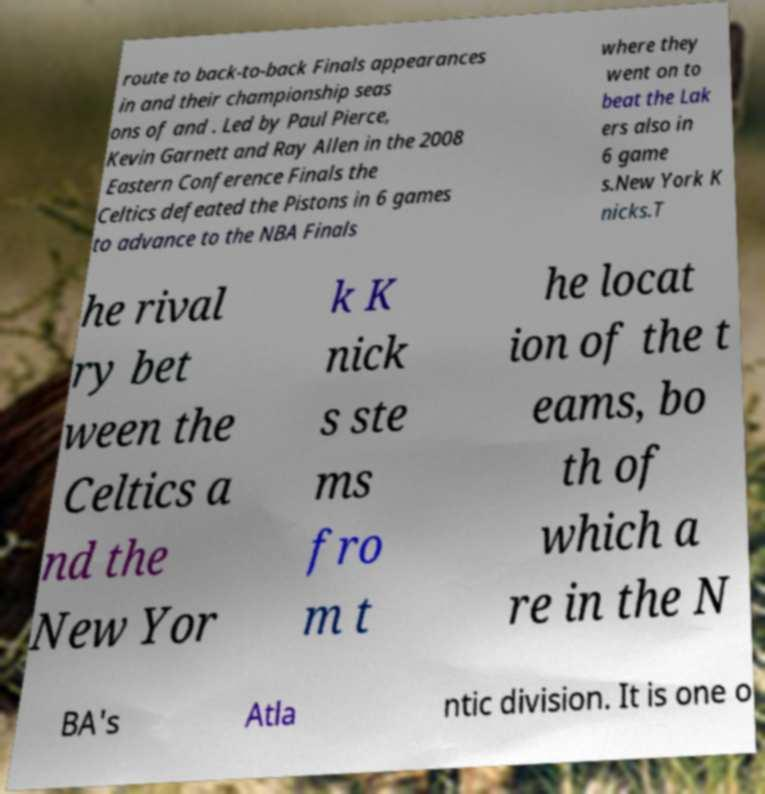Could you assist in decoding the text presented in this image and type it out clearly? route to back-to-back Finals appearances in and their championship seas ons of and . Led by Paul Pierce, Kevin Garnett and Ray Allen in the 2008 Eastern Conference Finals the Celtics defeated the Pistons in 6 games to advance to the NBA Finals where they went on to beat the Lak ers also in 6 game s.New York K nicks.T he rival ry bet ween the Celtics a nd the New Yor k K nick s ste ms fro m t he locat ion of the t eams, bo th of which a re in the N BA's Atla ntic division. It is one o 